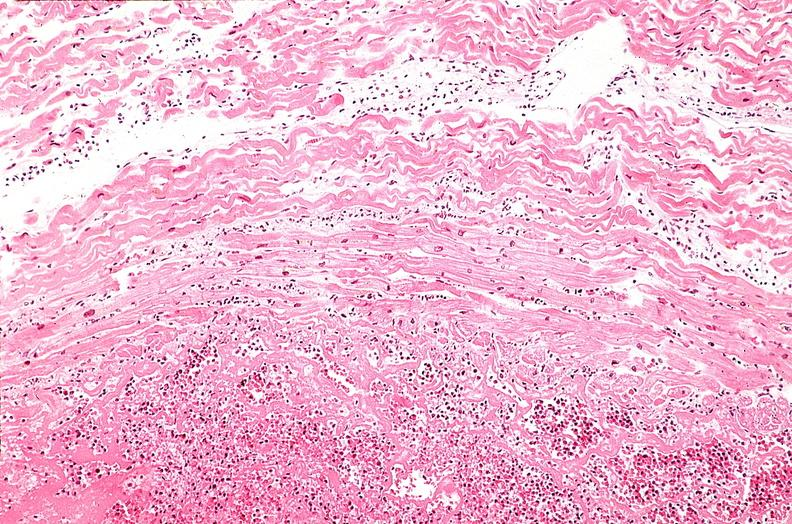does this section show heart, myocardial infarction, wavey fiber change, necrtosis, hemorrhage, and dissection?
Answer the question using a single word or phrase. No 